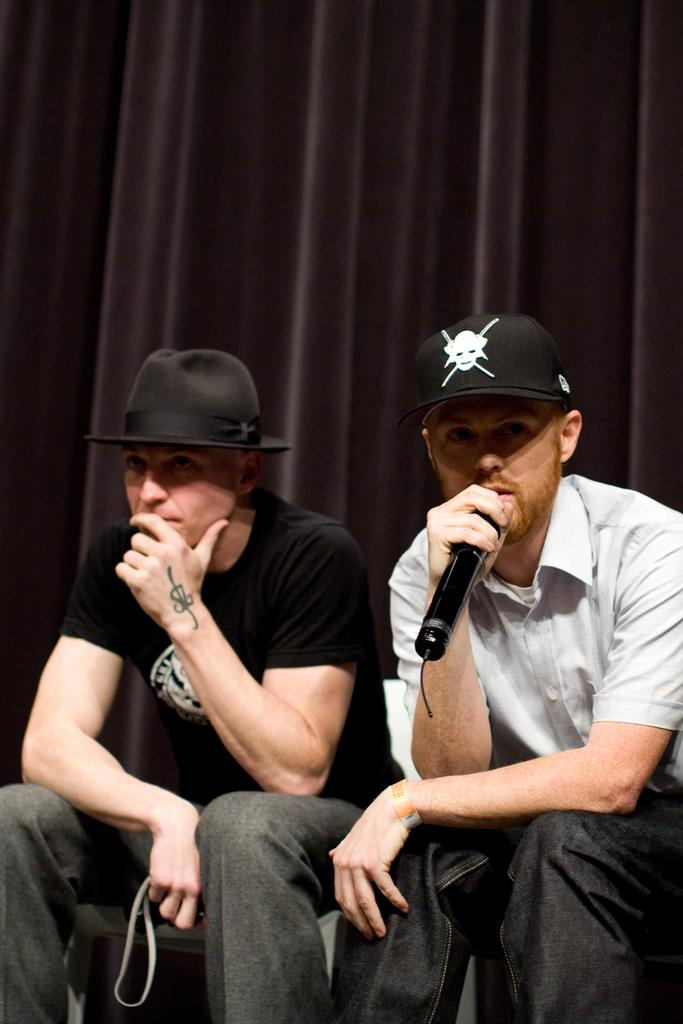What is the man in the image doing? The man is sitting in the image and holding a mic in his hand. What is the man wearing on his head? The man is wearing a black cap. Who is sitting beside the first man? There is another man sitting beside the first man. What is the second man wearing on his head? The second man is wearing a black color hat. What type of pet does the man have in the image? There is no pet visible in the image. How much wealth does the man have, as indicated by the image? The image does not provide any information about the man's wealth. 